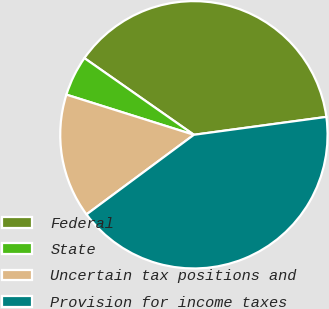Convert chart. <chart><loc_0><loc_0><loc_500><loc_500><pie_chart><fcel>Federal<fcel>State<fcel>Uncertain tax positions and<fcel>Provision for income taxes<nl><fcel>38.14%<fcel>4.87%<fcel>15.01%<fcel>41.99%<nl></chart> 